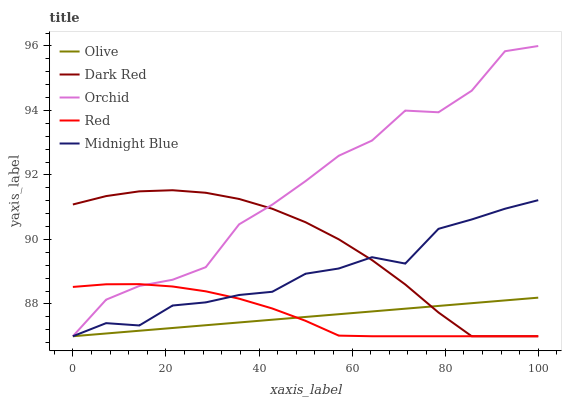Does Dark Red have the minimum area under the curve?
Answer yes or no. No. Does Dark Red have the maximum area under the curve?
Answer yes or no. No. Is Dark Red the smoothest?
Answer yes or no. No. Is Dark Red the roughest?
Answer yes or no. No. Does Dark Red have the highest value?
Answer yes or no. No. 